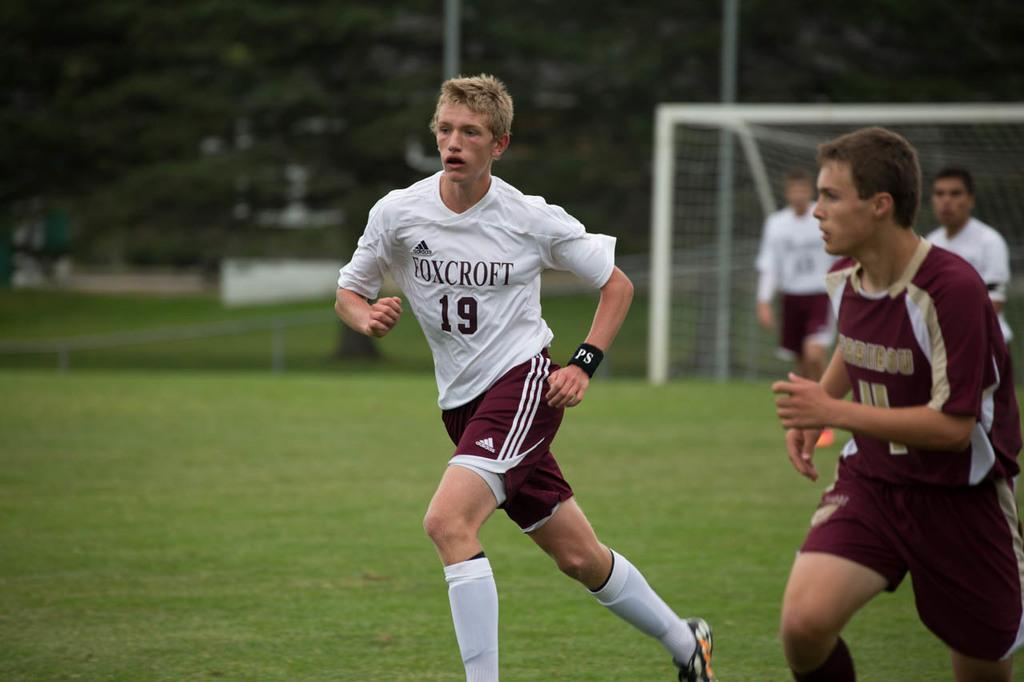Provide a one-sentence caption for the provided image. Number 19 from Foxcroft is running during a soccer game. 